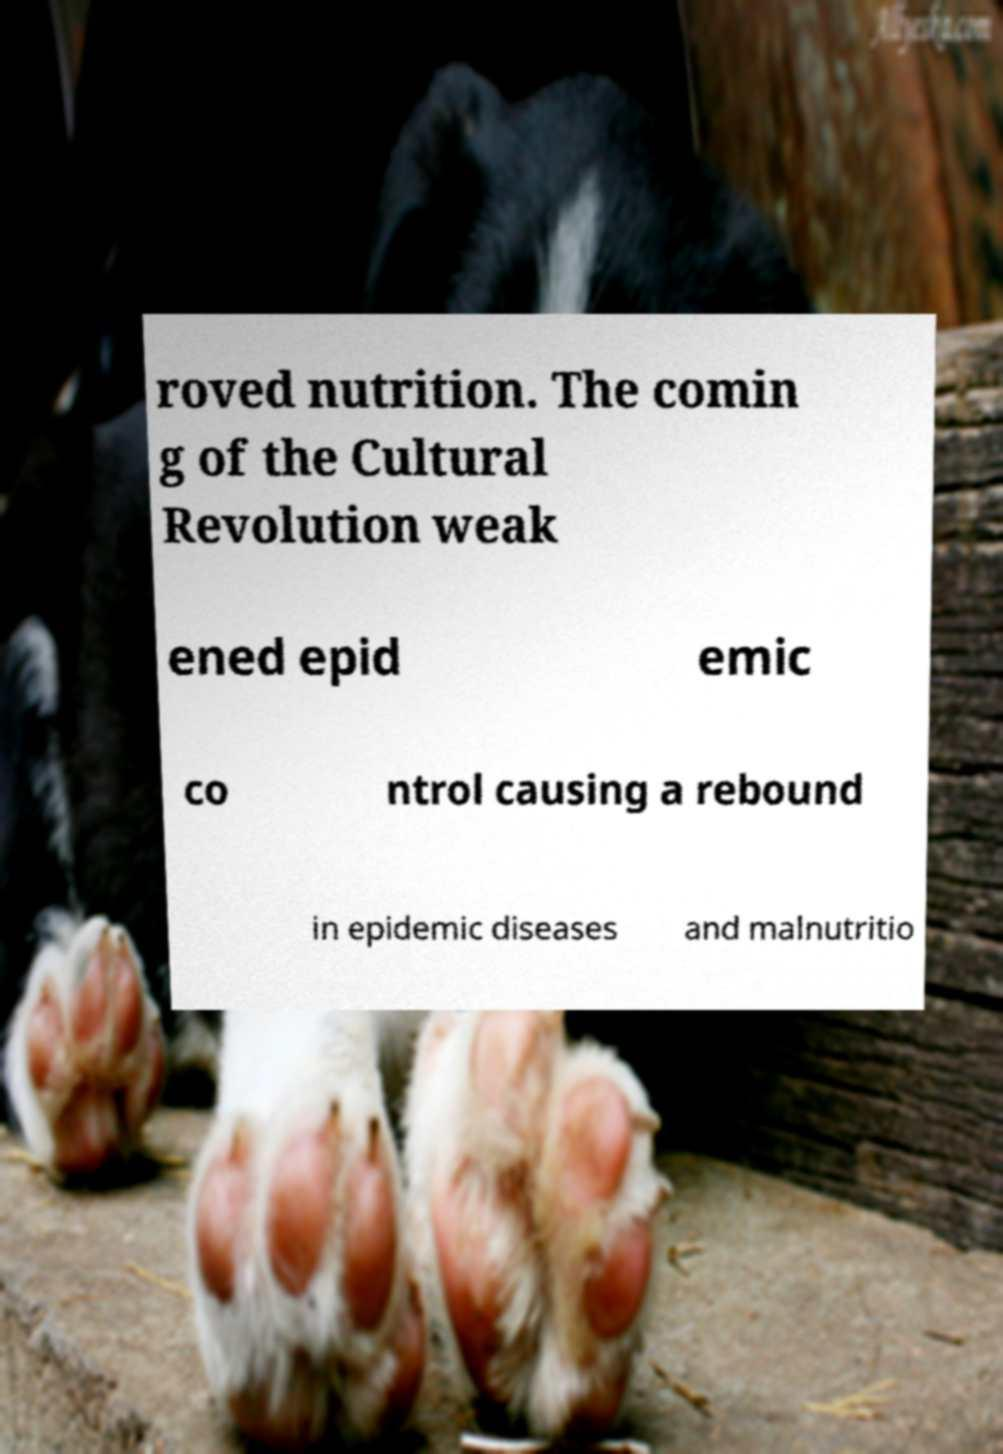What messages or text are displayed in this image? I need them in a readable, typed format. roved nutrition. The comin g of the Cultural Revolution weak ened epid emic co ntrol causing a rebound in epidemic diseases and malnutritio 